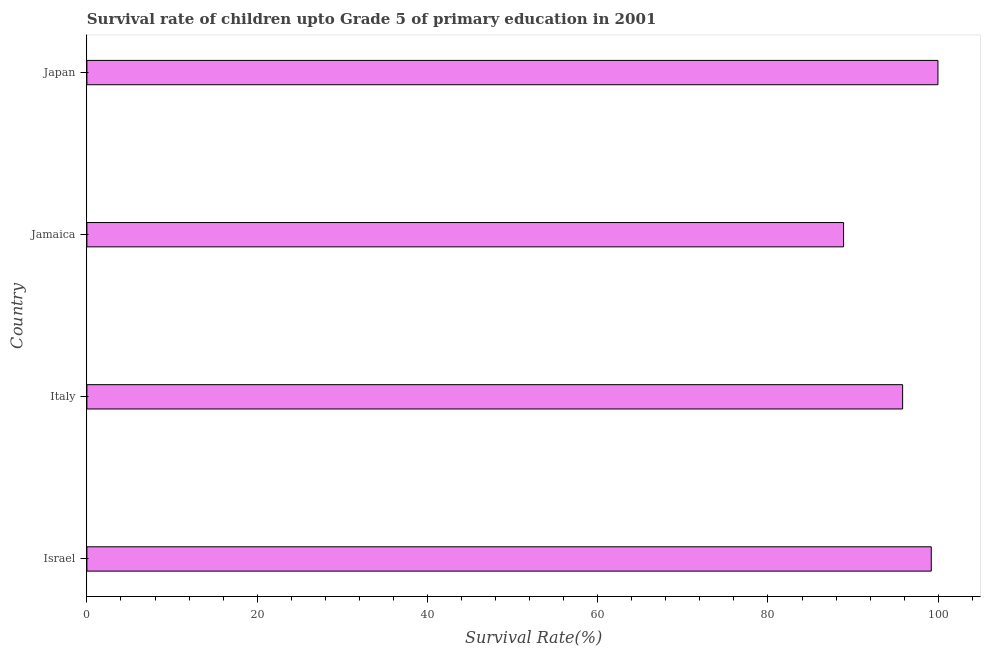Does the graph contain any zero values?
Provide a succinct answer. No. Does the graph contain grids?
Ensure brevity in your answer.  No. What is the title of the graph?
Your answer should be very brief. Survival rate of children upto Grade 5 of primary education in 2001 . What is the label or title of the X-axis?
Provide a short and direct response. Survival Rate(%). What is the label or title of the Y-axis?
Give a very brief answer. Country. What is the survival rate in Japan?
Provide a short and direct response. 99.97. Across all countries, what is the maximum survival rate?
Offer a terse response. 99.97. Across all countries, what is the minimum survival rate?
Make the answer very short. 88.88. In which country was the survival rate minimum?
Ensure brevity in your answer.  Jamaica. What is the sum of the survival rate?
Your answer should be compact. 383.85. What is the difference between the survival rate in Israel and Italy?
Ensure brevity in your answer.  3.36. What is the average survival rate per country?
Your response must be concise. 95.96. What is the median survival rate?
Offer a terse response. 97.5. In how many countries, is the survival rate greater than 4 %?
Your answer should be compact. 4. What is the ratio of the survival rate in Israel to that in Italy?
Offer a very short reply. 1.03. Is the survival rate in Israel less than that in Italy?
Your answer should be very brief. No. Is the difference between the survival rate in Italy and Japan greater than the difference between any two countries?
Make the answer very short. No. What is the difference between the highest and the second highest survival rate?
Offer a terse response. 0.78. What is the difference between the highest and the lowest survival rate?
Give a very brief answer. 11.08. How many bars are there?
Keep it short and to the point. 4. What is the Survival Rate(%) of Israel?
Provide a short and direct response. 99.18. What is the Survival Rate(%) of Italy?
Your response must be concise. 95.82. What is the Survival Rate(%) of Jamaica?
Offer a very short reply. 88.88. What is the Survival Rate(%) in Japan?
Make the answer very short. 99.97. What is the difference between the Survival Rate(%) in Israel and Italy?
Your response must be concise. 3.36. What is the difference between the Survival Rate(%) in Israel and Jamaica?
Your answer should be very brief. 10.3. What is the difference between the Survival Rate(%) in Israel and Japan?
Provide a short and direct response. -0.78. What is the difference between the Survival Rate(%) in Italy and Jamaica?
Your response must be concise. 6.94. What is the difference between the Survival Rate(%) in Italy and Japan?
Offer a terse response. -4.15. What is the difference between the Survival Rate(%) in Jamaica and Japan?
Keep it short and to the point. -11.08. What is the ratio of the Survival Rate(%) in Israel to that in Italy?
Your answer should be very brief. 1.03. What is the ratio of the Survival Rate(%) in Israel to that in Jamaica?
Your response must be concise. 1.12. What is the ratio of the Survival Rate(%) in Italy to that in Jamaica?
Provide a succinct answer. 1.08. What is the ratio of the Survival Rate(%) in Jamaica to that in Japan?
Your answer should be compact. 0.89. 